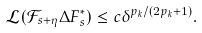Convert formula to latex. <formula><loc_0><loc_0><loc_500><loc_500>\mathcal { L } ( \mathcal { F } _ { s + \eta } \Delta F ^ { * } _ { s } ) \leq c \delta ^ { p _ { k } / ( 2 p _ { k } + 1 ) } .</formula> 